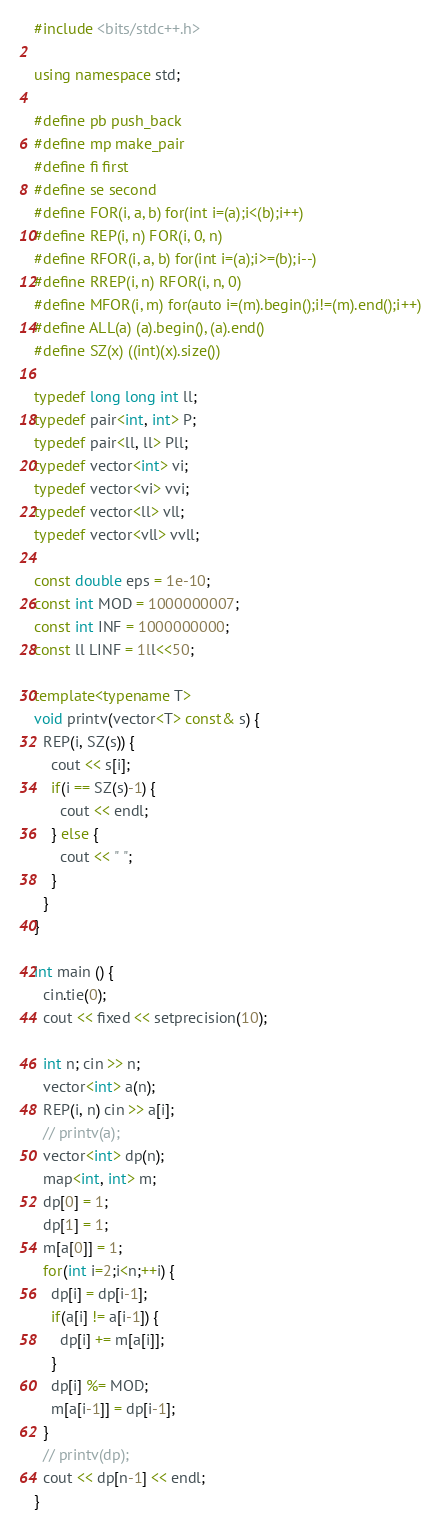<code> <loc_0><loc_0><loc_500><loc_500><_C++_>#include <bits/stdc++.h>

using namespace std;

#define pb push_back
#define mp make_pair
#define fi first
#define se second
#define FOR(i, a, b) for(int i=(a);i<(b);i++)
#define REP(i, n) FOR(i, 0, n)
#define RFOR(i, a, b) for(int i=(a);i>=(b);i--)
#define RREP(i, n) RFOR(i, n, 0)
#define MFOR(i, m) for(auto i=(m).begin();i!=(m).end();i++)
#define ALL(a) (a).begin(), (a).end()
#define SZ(x) ((int)(x).size())

typedef long long int ll;
typedef pair<int, int> P;
typedef pair<ll, ll> Pll;
typedef vector<int> vi;
typedef vector<vi> vvi;
typedef vector<ll> vll;
typedef vector<vll> vvll;

const double eps = 1e-10;
const int MOD = 1000000007;
const int INF = 1000000000;
const ll LINF = 1ll<<50;

template<typename T>
void printv(vector<T> const& s) {
  REP(i, SZ(s)) {
    cout << s[i];
    if(i == SZ(s)-1) {
      cout << endl;
    } else {
      cout << " ";
    }
  }
}

int main () {
  cin.tie(0);
  cout << fixed << setprecision(10);

  int n; cin >> n;
  vector<int> a(n);
  REP(i, n) cin >> a[i];
  // printv(a);
  vector<int> dp(n);
  map<int, int> m;
  dp[0] = 1;
  dp[1] = 1;
  m[a[0]] = 1;
  for(int i=2;i<n;++i) {
    dp[i] = dp[i-1];
    if(a[i] != a[i-1]) {
      dp[i] += m[a[i]];
    }
    dp[i] %= MOD;
    m[a[i-1]] = dp[i-1];
  }
  // printv(dp);
  cout << dp[n-1] << endl;
}
</code> 